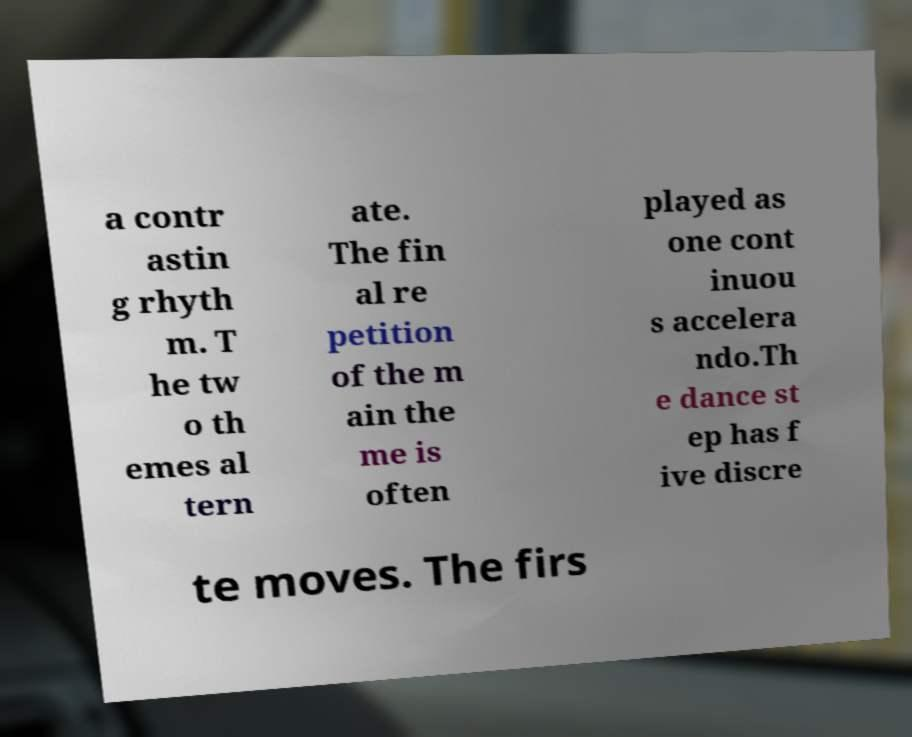Please identify and transcribe the text found in this image. a contr astin g rhyth m. T he tw o th emes al tern ate. The fin al re petition of the m ain the me is often played as one cont inuou s accelera ndo.Th e dance st ep has f ive discre te moves. The firs 